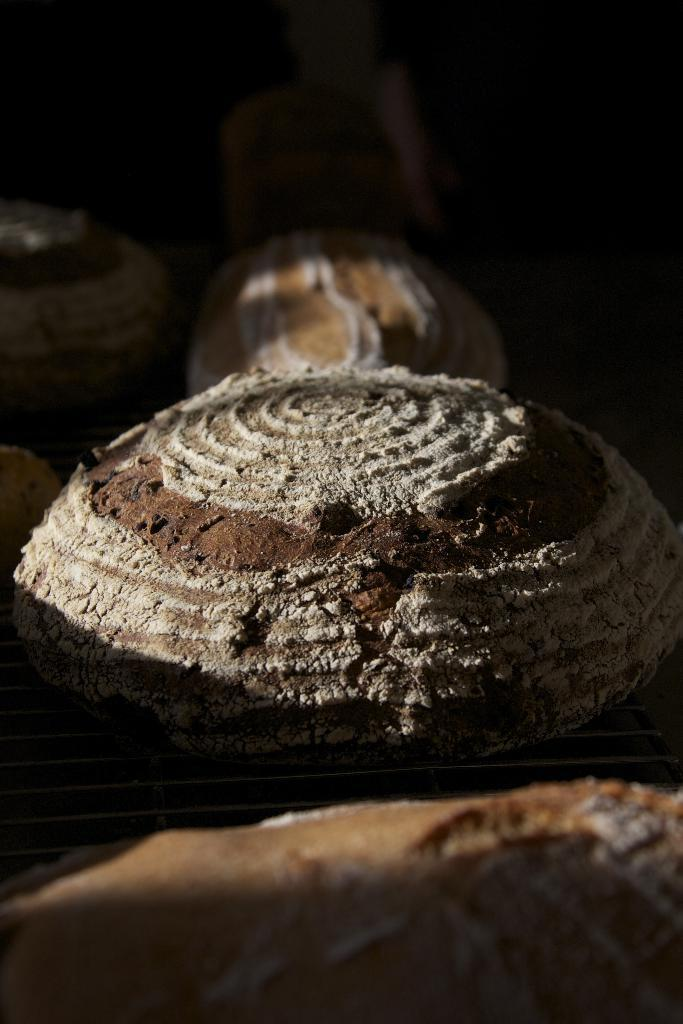What is the shape of the main structure in the image? The main structure in the image is round. What color is the main structure in the image? The main structure is brown in color. What can be seen in the background of the image? There are other structures visible in the background of the image. What type of plastic is covering the drain in the image? There is no drain or plastic present in the image; it features a round, brown structure and other structures in the background. 